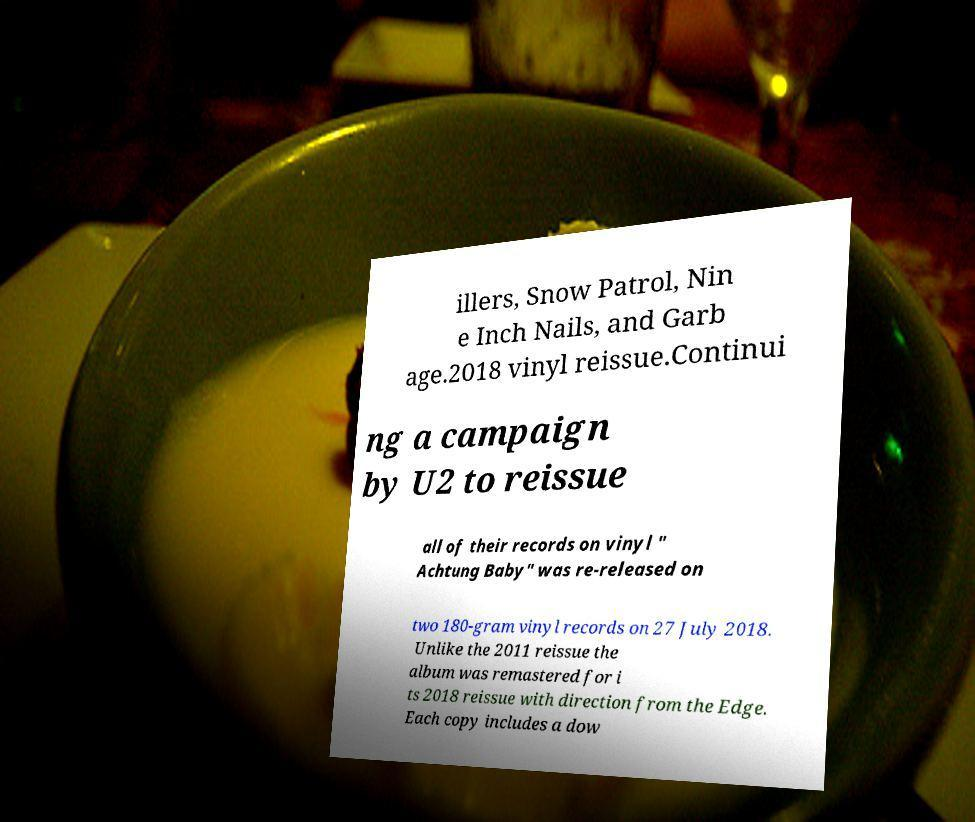There's text embedded in this image that I need extracted. Can you transcribe it verbatim? illers, Snow Patrol, Nin e Inch Nails, and Garb age.2018 vinyl reissue.Continui ng a campaign by U2 to reissue all of their records on vinyl " Achtung Baby" was re-released on two 180-gram vinyl records on 27 July 2018. Unlike the 2011 reissue the album was remastered for i ts 2018 reissue with direction from the Edge. Each copy includes a dow 